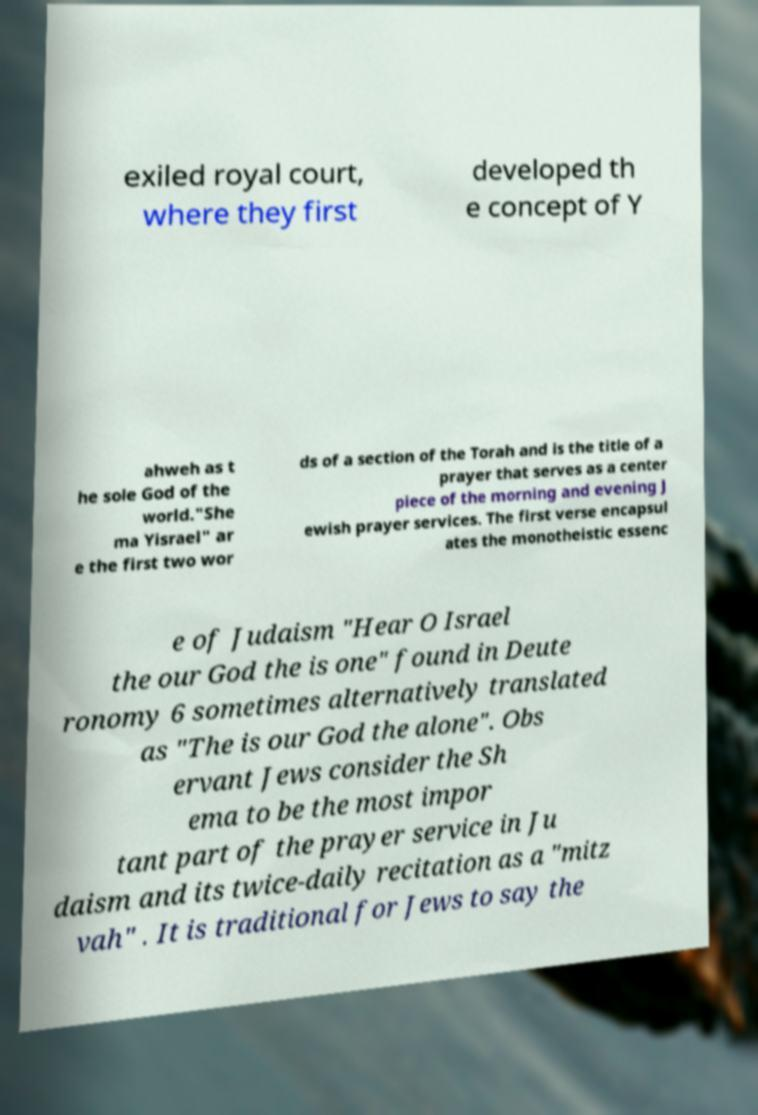Can you read and provide the text displayed in the image?This photo seems to have some interesting text. Can you extract and type it out for me? exiled royal court, where they first developed th e concept of Y ahweh as t he sole God of the world."She ma Yisrael" ar e the first two wor ds of a section of the Torah and is the title of a prayer that serves as a center piece of the morning and evening J ewish prayer services. The first verse encapsul ates the monotheistic essenc e of Judaism "Hear O Israel the our God the is one" found in Deute ronomy 6 sometimes alternatively translated as "The is our God the alone". Obs ervant Jews consider the Sh ema to be the most impor tant part of the prayer service in Ju daism and its twice-daily recitation as a "mitz vah" . It is traditional for Jews to say the 